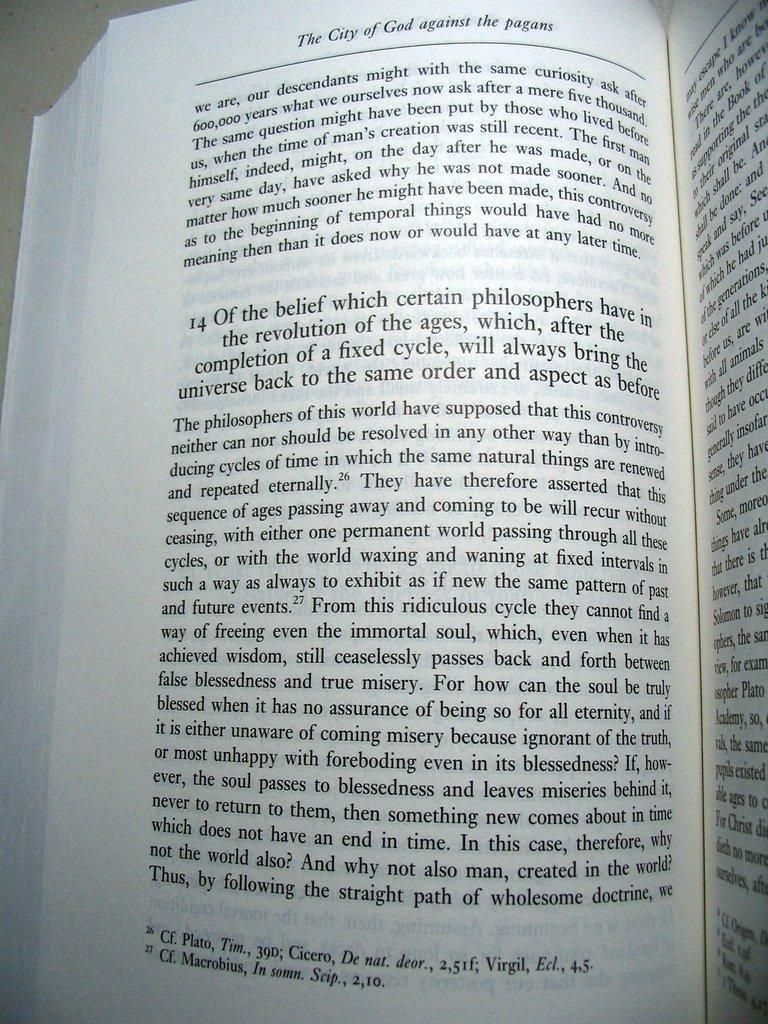<image>
Share a concise interpretation of the image provided. A book open to a page and at the top it says the city of god against the pagans 